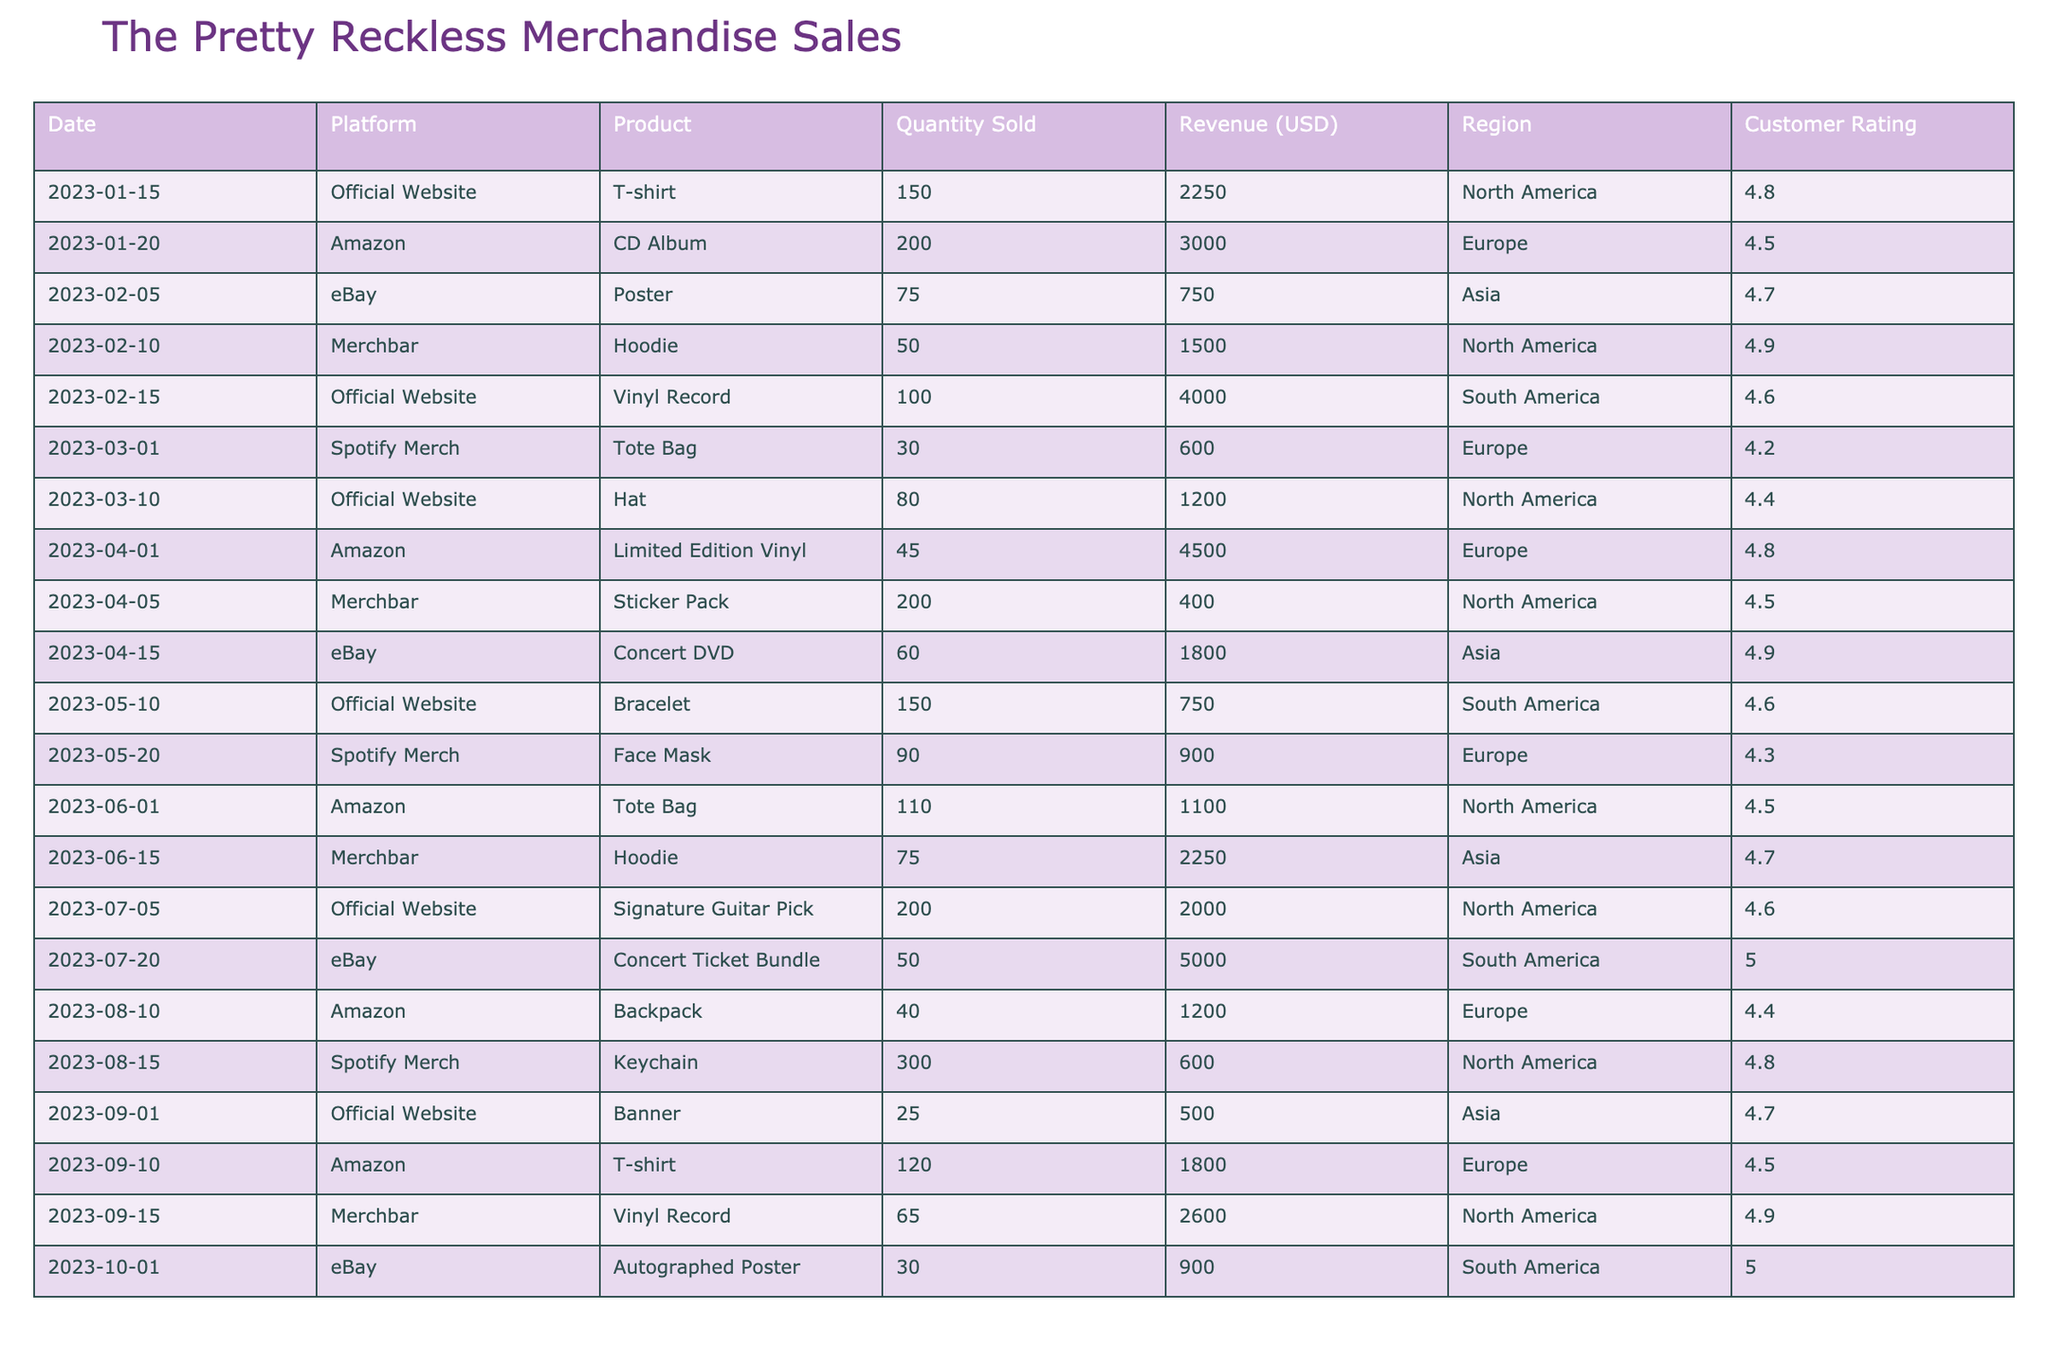What's the total revenue generated from merchandise sales in North America? To find the total revenue from North America, we look at all the sales in that region: 2250 (T-shirt) + 1500 (Hoodie) + 1200 (Hat) + 750 (Bracelet) + 2000 (Signature Guitar Pick) + 500 (Banner). Adding these together gives 2250 + 1500 + 1200 + 750 + 2000 + 500 = 8200.
Answer: 8200 Which product sold the most units overall? We need to check the Quantity Sold for all products. The highest amounts are 300 (Keychain) from the Spotify Merch and 250 (CD Album) from Amazon. The Keychain has sold the highest units with 300.
Answer: Keychain What was the customer rating for the Concert Ticket Bundle sold on eBay? The table directly states that the customer rating for the Concert Ticket Bundle is 5.0.
Answer: 5.0 What is the average customer rating across all products sold? To find the average rating, we sum all the customer ratings: 4.8 + 4.5 + 4.7 + 4.9 + 4.6 + 4.2 + 4.4 + 4.8 + 4.6 + 4.3 + 4.5 + 4.7 + 4.9 + 5.0 = 64.8. The total number of ratings is 14. Therefore, the average is 64.8 / 14 = 4.63.
Answer: 4.63 Did the Official Website sell more merchandise than Amazon and eBay combined? First, we compute revenue from the Official Website: 2250 + 4000 + 1200 + 750 + 2000 + 500 = 11200. Now for Amazon and eBay combined: 3000 (Amazon) + 9000 (eBay) = 12000. Since 11200 < 12000, the Official Website did not sell more.
Answer: No What is the total quantity of vinyl records sold across all platforms? We need to look for the quantity sold for vinyl records. There are two entries: 100 (from Official Website) and 65 (from Merchbar). Summing these gives us 100 + 65 = 165.
Answer: 165 What was the revenue generated from the Hoodie sold on Merchbar compared to the one sold on the Official Website? The revenue for the Hoodie sold on Merchbar is 2250 and the Hoodie from the Official Website is not listed. However, 50 hoodies were sold on Merchbar. Therefore, only the Merchbar revenue is considered, which is 2250 USD.
Answer: 2250 Which platform had the highest gross revenue from merchandise sales, and what was that amount? To find this, we calculate the total revenue for each platform: Official Website = 11200, Amazon = 9000, eBay = 6850, Spotify Merch = 2100, and Merchbar = 3000. The highest revenue is from the Official Website with 11200.
Answer: Official Website, 11200 How much did the total sales from South America contribute to the overall revenue? The sales from South America are as follows: 4000 (Vinyl Record) + 750 (Bracelet) + 5000 (Concert Ticket Bundle) = 4000 + 750 + 5000 = 9750. This is the total revenue from South America.
Answer: 9750 